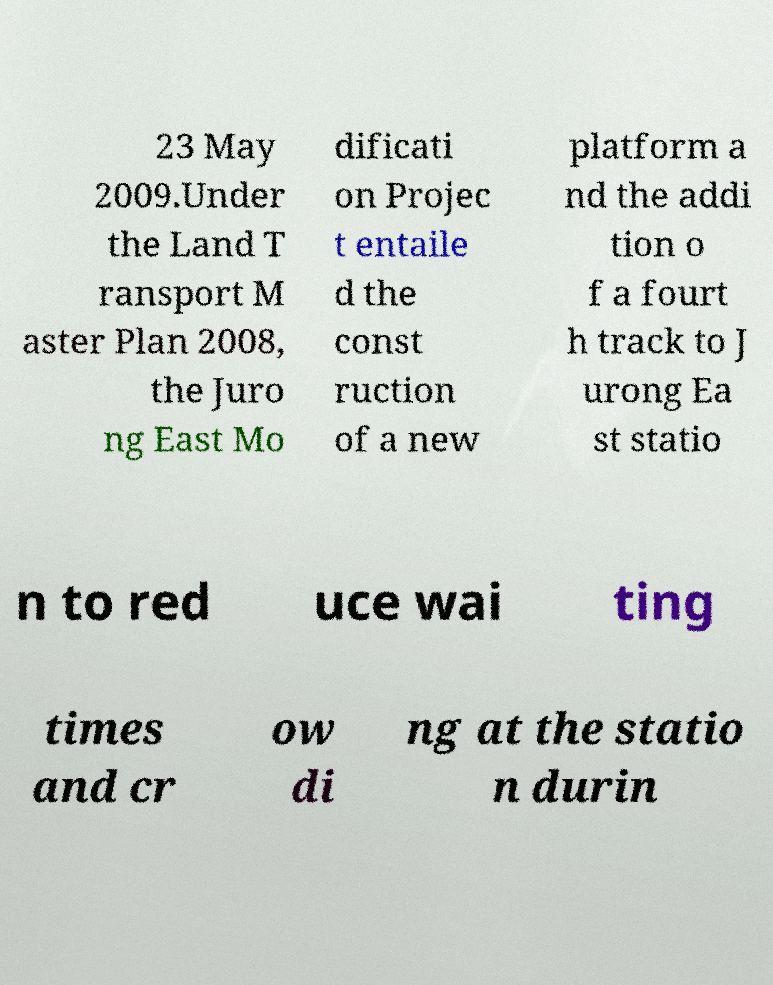Can you read and provide the text displayed in the image?This photo seems to have some interesting text. Can you extract and type it out for me? 23 May 2009.Under the Land T ransport M aster Plan 2008, the Juro ng East Mo dificati on Projec t entaile d the const ruction of a new platform a nd the addi tion o f a fourt h track to J urong Ea st statio n to red uce wai ting times and cr ow di ng at the statio n durin 